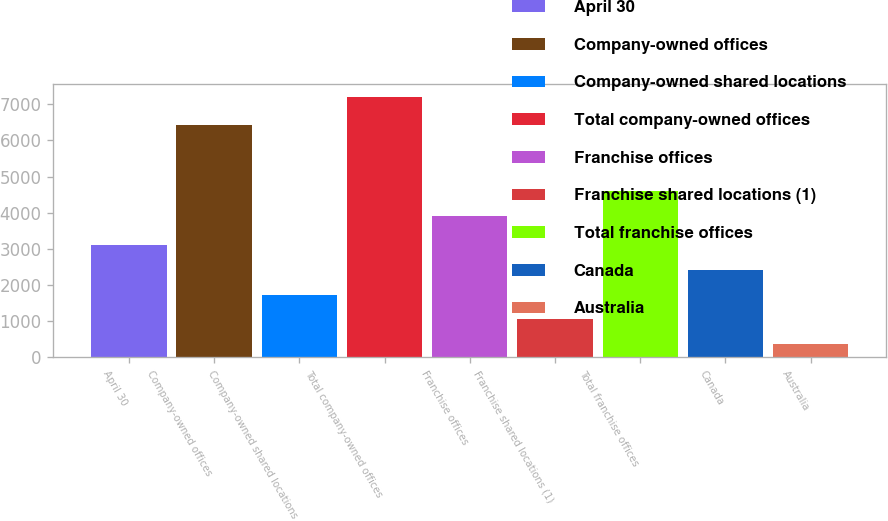<chart> <loc_0><loc_0><loc_500><loc_500><bar_chart><fcel>April 30<fcel>Company-owned offices<fcel>Company-owned shared locations<fcel>Total company-owned offices<fcel>Franchise offices<fcel>Franchise shared locations (1)<fcel>Total franchise offices<fcel>Canada<fcel>Australia<nl><fcel>3100.8<fcel>6431<fcel>1737.4<fcel>7191<fcel>3909<fcel>1055.7<fcel>4590.7<fcel>2419.1<fcel>374<nl></chart> 